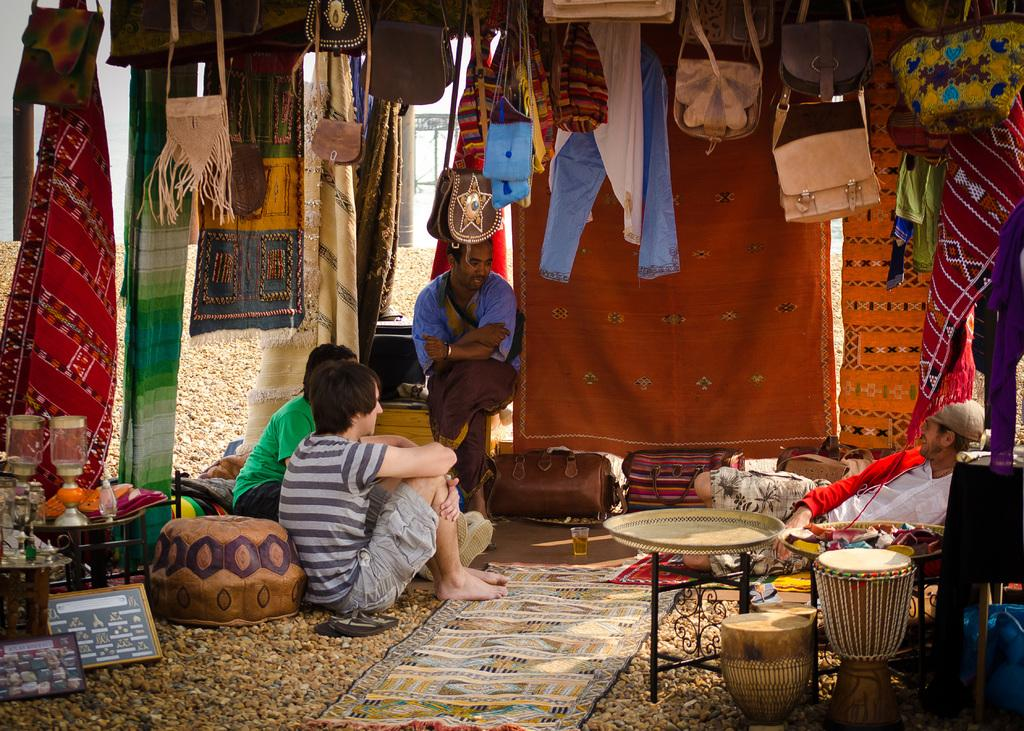How many people are in the image? There is a group of people in the image, but the exact number is not specified. What are the people in the image doing? The people are seated in the image. What items can be seen related to travel or personal belongings? Baggage and a wallet are visible in the image. What type of items can be seen related to clothing? There are clothes in the image. Are there any other objects in the image that are not specified? Yes, there are some unspecified objects in the image. What type of coal can be seen in the image? There is no coal present in the image. What songs are being sung by the people in the image? There is no indication of any songs being sung in the image. 